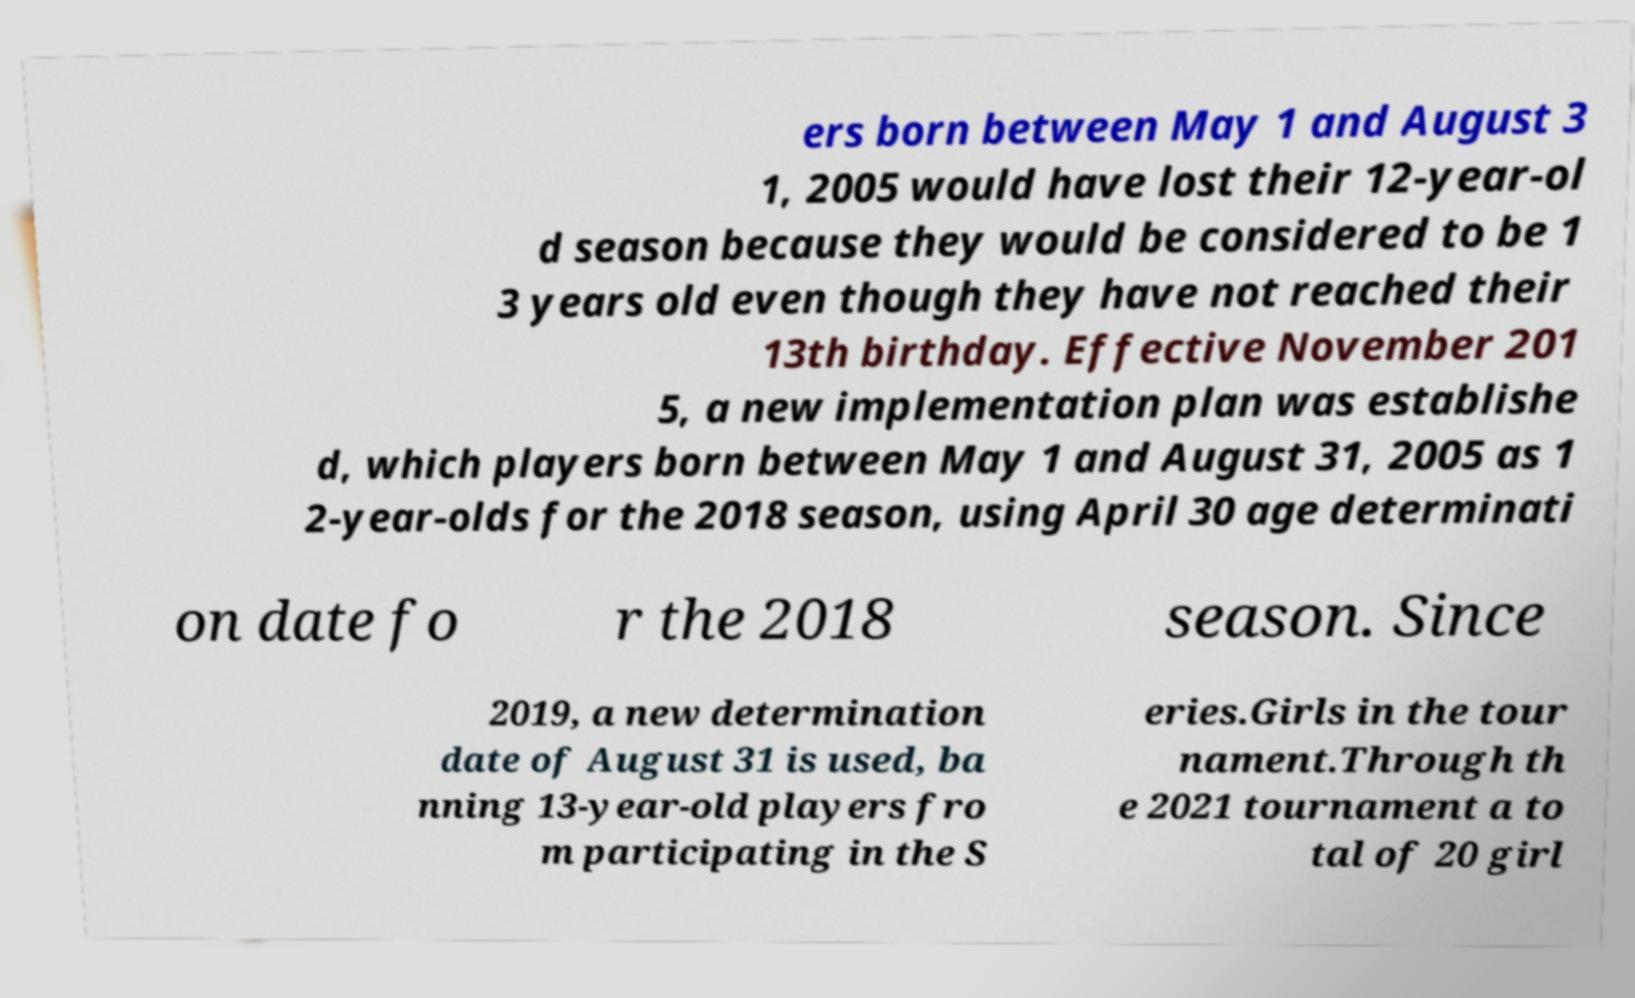Could you assist in decoding the text presented in this image and type it out clearly? ers born between May 1 and August 3 1, 2005 would have lost their 12-year-ol d season because they would be considered to be 1 3 years old even though they have not reached their 13th birthday. Effective November 201 5, a new implementation plan was establishe d, which players born between May 1 and August 31, 2005 as 1 2-year-olds for the 2018 season, using April 30 age determinati on date fo r the 2018 season. Since 2019, a new determination date of August 31 is used, ba nning 13-year-old players fro m participating in the S eries.Girls in the tour nament.Through th e 2021 tournament a to tal of 20 girl 